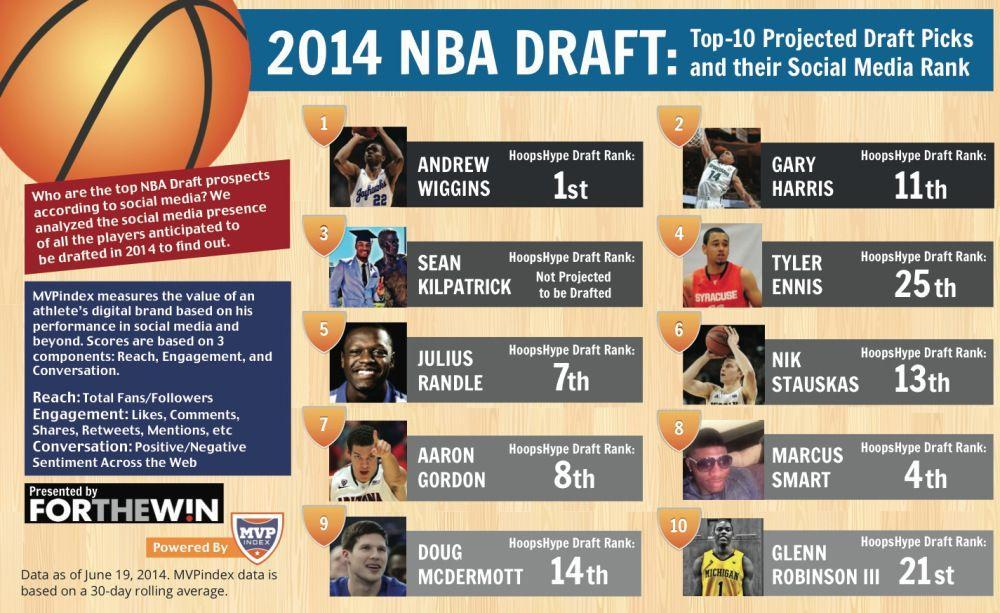How many players are in this infographic?
Answer the question with a short phrase. 10 How many players have rank in-between 2 and 10? 3 How many players have rank in-between 20 and 26? 2 